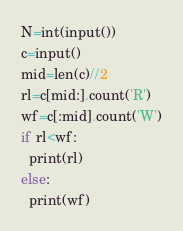<code> <loc_0><loc_0><loc_500><loc_500><_Python_>N=int(input())
c=input()
mid=len(c)//2
rl=c[mid:].count('R')
wf=c[:mid].count('W')
if rl<wf:
  print(rl)
else:
  print(wf)</code> 